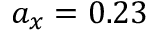<formula> <loc_0><loc_0><loc_500><loc_500>a _ { x } = 0 . 2 3</formula> 